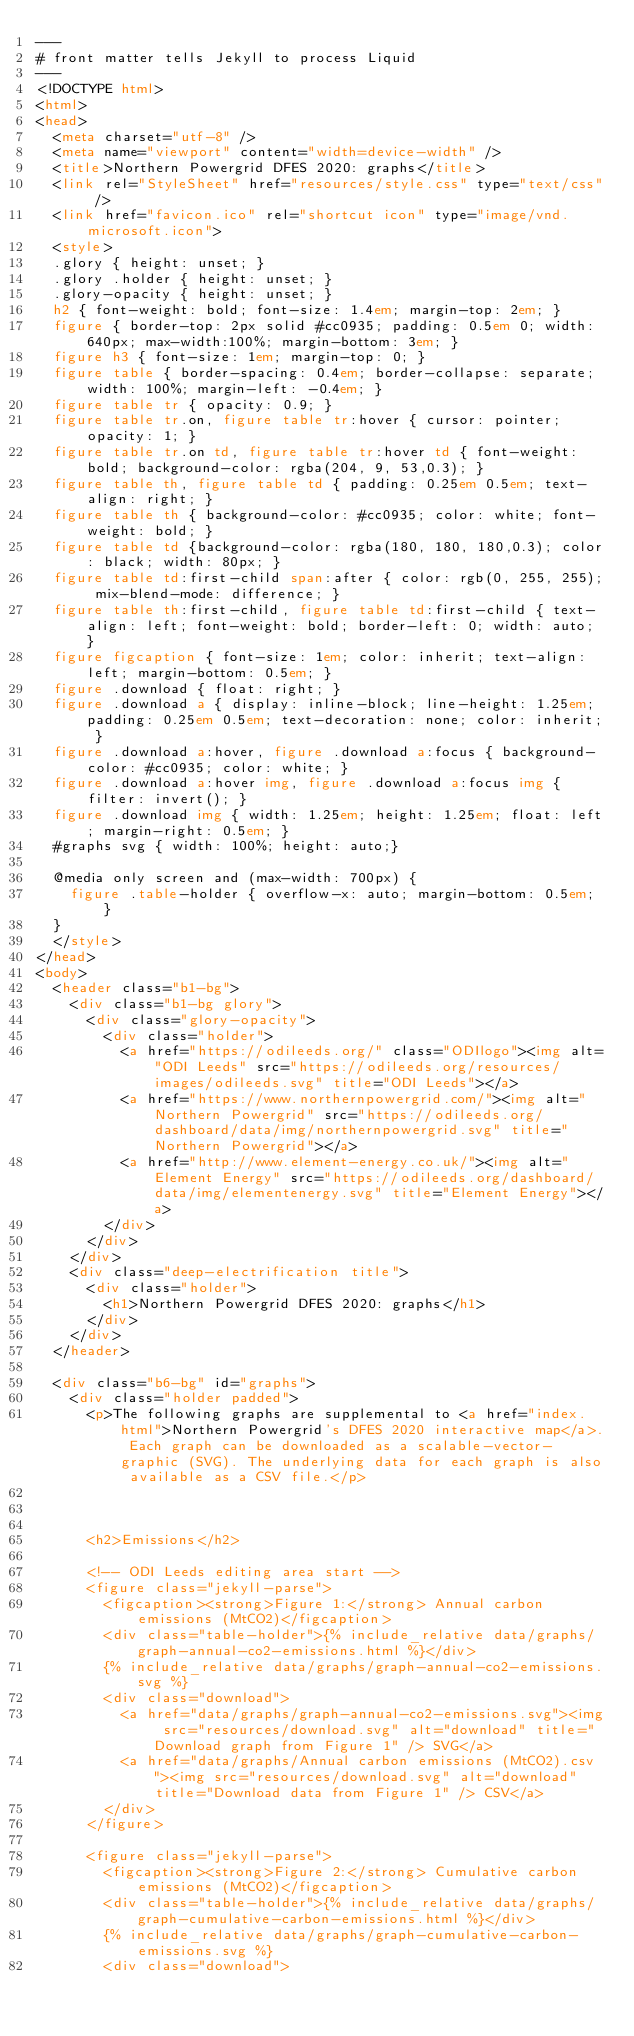Convert code to text. <code><loc_0><loc_0><loc_500><loc_500><_HTML_>---
# front matter tells Jekyll to process Liquid
---
<!DOCTYPE html>
<html>
<head>
	<meta charset="utf-8" />
	<meta name="viewport" content="width=device-width" />
	<title>Northern Powergrid DFES 2020: graphs</title>
	<link rel="StyleSheet" href="resources/style.css" type="text/css" />
	<link href="favicon.ico" rel="shortcut icon" type="image/vnd.microsoft.icon">
	<style>
	.glory { height: unset; }
	.glory .holder { height: unset; }
	.glory-opacity { height: unset; }
	h2 { font-weight: bold; font-size: 1.4em; margin-top: 2em; }
	figure { border-top: 2px solid #cc0935; padding: 0.5em 0; width: 640px; max-width:100%; margin-bottom: 3em; }
	figure h3 { font-size: 1em; margin-top: 0; }
	figure table { border-spacing: 0.4em; border-collapse: separate; width: 100%; margin-left: -0.4em; }
	figure table tr { opacity: 0.9; }
	figure table tr.on, figure table tr:hover { cursor: pointer; opacity: 1; }
	figure table tr.on td, figure table tr:hover td { font-weight: bold; background-color: rgba(204, 9, 53,0.3); }
	figure table th, figure table td { padding: 0.25em 0.5em; text-align: right; }
	figure table th { background-color: #cc0935; color: white; font-weight: bold; }
	figure table td {background-color: rgba(180, 180, 180,0.3); color: black; width: 80px; }
	figure table td:first-child span:after { color: rgb(0, 255, 255); mix-blend-mode: difference; }
	figure table th:first-child, figure table td:first-child { text-align: left; font-weight: bold; border-left: 0; width: auto; }
	figure figcaption { font-size: 1em; color: inherit; text-align: left; margin-bottom: 0.5em; }
	figure .download { float: right; }
	figure .download a { display: inline-block; line-height: 1.25em; padding: 0.25em 0.5em; text-decoration: none; color: inherit; }
	figure .download a:hover, figure .download a:focus { background-color: #cc0935; color: white; }
	figure .download a:hover img, figure .download a:focus img { filter: invert(); }
	figure .download img { width: 1.25em; height: 1.25em; float: left; margin-right: 0.5em; }
	#graphs svg { width: 100%; height: auto;}

	@media only screen and (max-width: 700px) {
		figure .table-holder { overflow-x: auto; margin-bottom: 0.5em; }
	}
	</style>
</head>
<body>
	<header class="b1-bg">
		<div class="b1-bg glory">
			<div class="glory-opacity">
				<div class="holder">
					<a href="https://odileeds.org/" class="ODIlogo"><img alt="ODI Leeds" src="https://odileeds.org/resources/images/odileeds.svg" title="ODI Leeds"></a>
					<a href="https://www.northernpowergrid.com/"><img alt="Northern Powergrid" src="https://odileeds.org/dashboard/data/img/northernpowergrid.svg" title="Northern Powergrid"></a>
					<a href="http://www.element-energy.co.uk/"><img alt="Element Energy" src="https://odileeds.org/dashboard/data/img/elementenergy.svg" title="Element Energy"></a>
				</div>
			</div>
		</div>
		<div class="deep-electrification title">
			<div class="holder">
				<h1>Northern Powergrid DFES 2020: graphs</h1>
			</div>
		</div>
	</header>

	<div class="b6-bg" id="graphs">
		<div class="holder padded">
			<p>The following graphs are supplemental to <a href="index.html">Northern Powergrid's DFES 2020 interactive map</a>. Each graph can be downloaded as a scalable-vector-graphic (SVG). The underlying data for each graph is also available as a CSV file.</p>
	
	
	
			<h2>Emissions</h2>

			<!-- ODI Leeds editing area start -->
			<figure class="jekyll-parse">
				<figcaption><strong>Figure 1:</strong> Annual carbon emissions (MtCO2)</figcaption>
				<div class="table-holder">{% include_relative data/graphs/graph-annual-co2-emissions.html %}</div>
				{% include_relative data/graphs/graph-annual-co2-emissions.svg %}
				<div class="download">
					<a href="data/graphs/graph-annual-co2-emissions.svg"><img src="resources/download.svg" alt="download" title="Download graph from Figure 1" /> SVG</a>
					<a href="data/graphs/Annual carbon emissions (MtCO2).csv"><img src="resources/download.svg" alt="download" title="Download data from Figure 1" /> CSV</a>
				</div>
			</figure>

			<figure class="jekyll-parse">
				<figcaption><strong>Figure 2:</strong> Cumulative carbon emissions (MtCO2)</figcaption>
				<div class="table-holder">{% include_relative data/graphs/graph-cumulative-carbon-emissions.html %}</div>
				{% include_relative data/graphs/graph-cumulative-carbon-emissions.svg %}
				<div class="download"></code> 